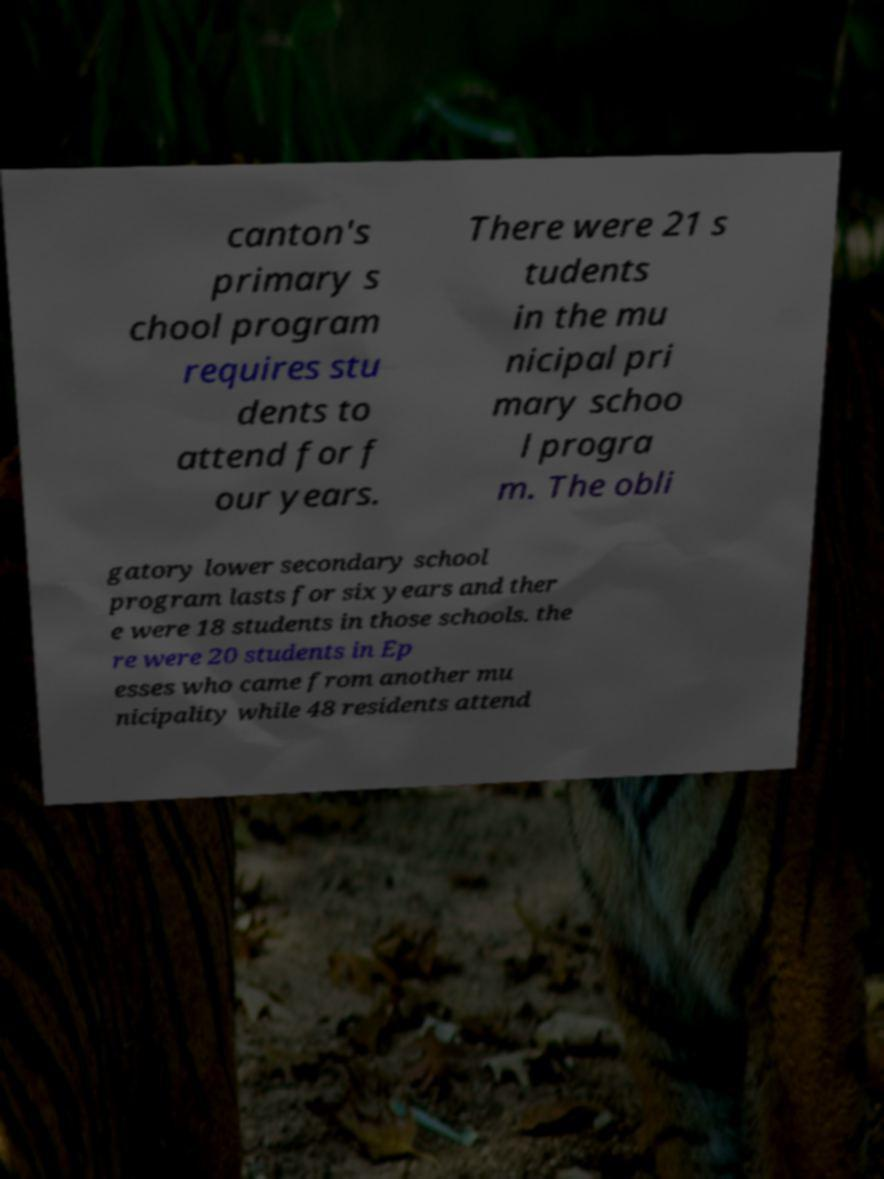What messages or text are displayed in this image? I need them in a readable, typed format. canton's primary s chool program requires stu dents to attend for f our years. There were 21 s tudents in the mu nicipal pri mary schoo l progra m. The obli gatory lower secondary school program lasts for six years and ther e were 18 students in those schools. the re were 20 students in Ep esses who came from another mu nicipality while 48 residents attend 